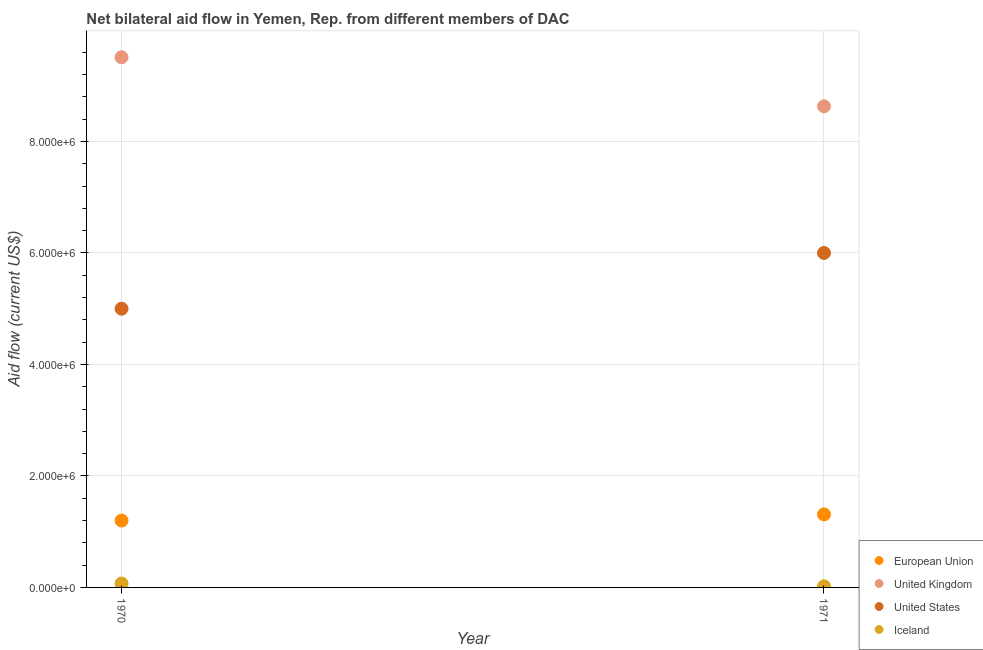How many different coloured dotlines are there?
Provide a succinct answer. 4. What is the amount of aid given by eu in 1971?
Your answer should be very brief. 1.31e+06. Across all years, what is the maximum amount of aid given by eu?
Your answer should be compact. 1.31e+06. Across all years, what is the minimum amount of aid given by eu?
Keep it short and to the point. 1.20e+06. In which year was the amount of aid given by us maximum?
Your response must be concise. 1971. In which year was the amount of aid given by us minimum?
Make the answer very short. 1970. What is the total amount of aid given by uk in the graph?
Your answer should be compact. 1.81e+07. What is the difference between the amount of aid given by iceland in 1970 and that in 1971?
Offer a very short reply. 5.00e+04. What is the difference between the amount of aid given by iceland in 1970 and the amount of aid given by us in 1971?
Offer a terse response. -5.93e+06. What is the average amount of aid given by us per year?
Provide a short and direct response. 5.50e+06. In the year 1971, what is the difference between the amount of aid given by us and amount of aid given by eu?
Make the answer very short. 4.69e+06. What is the ratio of the amount of aid given by uk in 1970 to that in 1971?
Keep it short and to the point. 1.1. Is the amount of aid given by uk in 1970 less than that in 1971?
Your answer should be very brief. No. In how many years, is the amount of aid given by eu greater than the average amount of aid given by eu taken over all years?
Your response must be concise. 1. Does the amount of aid given by iceland monotonically increase over the years?
Your response must be concise. No. How many years are there in the graph?
Offer a very short reply. 2. Are the values on the major ticks of Y-axis written in scientific E-notation?
Provide a succinct answer. Yes. Does the graph contain any zero values?
Keep it short and to the point. No. Does the graph contain grids?
Offer a terse response. Yes. Where does the legend appear in the graph?
Give a very brief answer. Bottom right. How many legend labels are there?
Give a very brief answer. 4. How are the legend labels stacked?
Your answer should be very brief. Vertical. What is the title of the graph?
Ensure brevity in your answer.  Net bilateral aid flow in Yemen, Rep. from different members of DAC. Does "Management rating" appear as one of the legend labels in the graph?
Provide a succinct answer. No. What is the label or title of the Y-axis?
Offer a terse response. Aid flow (current US$). What is the Aid flow (current US$) of European Union in 1970?
Keep it short and to the point. 1.20e+06. What is the Aid flow (current US$) in United Kingdom in 1970?
Your answer should be compact. 9.51e+06. What is the Aid flow (current US$) in United States in 1970?
Make the answer very short. 5.00e+06. What is the Aid flow (current US$) in Iceland in 1970?
Your answer should be very brief. 7.00e+04. What is the Aid flow (current US$) in European Union in 1971?
Ensure brevity in your answer.  1.31e+06. What is the Aid flow (current US$) in United Kingdom in 1971?
Keep it short and to the point. 8.63e+06. What is the Aid flow (current US$) of United States in 1971?
Keep it short and to the point. 6.00e+06. What is the Aid flow (current US$) in Iceland in 1971?
Provide a succinct answer. 2.00e+04. Across all years, what is the maximum Aid flow (current US$) of European Union?
Your response must be concise. 1.31e+06. Across all years, what is the maximum Aid flow (current US$) in United Kingdom?
Provide a succinct answer. 9.51e+06. Across all years, what is the minimum Aid flow (current US$) in European Union?
Provide a short and direct response. 1.20e+06. Across all years, what is the minimum Aid flow (current US$) of United Kingdom?
Your response must be concise. 8.63e+06. What is the total Aid flow (current US$) of European Union in the graph?
Give a very brief answer. 2.51e+06. What is the total Aid flow (current US$) of United Kingdom in the graph?
Your answer should be very brief. 1.81e+07. What is the total Aid flow (current US$) of United States in the graph?
Give a very brief answer. 1.10e+07. What is the difference between the Aid flow (current US$) in European Union in 1970 and that in 1971?
Provide a short and direct response. -1.10e+05. What is the difference between the Aid flow (current US$) of United Kingdom in 1970 and that in 1971?
Give a very brief answer. 8.80e+05. What is the difference between the Aid flow (current US$) in Iceland in 1970 and that in 1971?
Offer a terse response. 5.00e+04. What is the difference between the Aid flow (current US$) in European Union in 1970 and the Aid flow (current US$) in United Kingdom in 1971?
Your answer should be very brief. -7.43e+06. What is the difference between the Aid flow (current US$) of European Union in 1970 and the Aid flow (current US$) of United States in 1971?
Make the answer very short. -4.80e+06. What is the difference between the Aid flow (current US$) of European Union in 1970 and the Aid flow (current US$) of Iceland in 1971?
Provide a succinct answer. 1.18e+06. What is the difference between the Aid flow (current US$) of United Kingdom in 1970 and the Aid flow (current US$) of United States in 1971?
Offer a terse response. 3.51e+06. What is the difference between the Aid flow (current US$) of United Kingdom in 1970 and the Aid flow (current US$) of Iceland in 1971?
Give a very brief answer. 9.49e+06. What is the difference between the Aid flow (current US$) of United States in 1970 and the Aid flow (current US$) of Iceland in 1971?
Ensure brevity in your answer.  4.98e+06. What is the average Aid flow (current US$) in European Union per year?
Your response must be concise. 1.26e+06. What is the average Aid flow (current US$) in United Kingdom per year?
Ensure brevity in your answer.  9.07e+06. What is the average Aid flow (current US$) of United States per year?
Give a very brief answer. 5.50e+06. What is the average Aid flow (current US$) in Iceland per year?
Make the answer very short. 4.50e+04. In the year 1970, what is the difference between the Aid flow (current US$) in European Union and Aid flow (current US$) in United Kingdom?
Offer a very short reply. -8.31e+06. In the year 1970, what is the difference between the Aid flow (current US$) in European Union and Aid flow (current US$) in United States?
Your answer should be very brief. -3.80e+06. In the year 1970, what is the difference between the Aid flow (current US$) in European Union and Aid flow (current US$) in Iceland?
Provide a short and direct response. 1.13e+06. In the year 1970, what is the difference between the Aid flow (current US$) of United Kingdom and Aid flow (current US$) of United States?
Offer a terse response. 4.51e+06. In the year 1970, what is the difference between the Aid flow (current US$) of United Kingdom and Aid flow (current US$) of Iceland?
Your answer should be compact. 9.44e+06. In the year 1970, what is the difference between the Aid flow (current US$) in United States and Aid flow (current US$) in Iceland?
Your answer should be very brief. 4.93e+06. In the year 1971, what is the difference between the Aid flow (current US$) in European Union and Aid flow (current US$) in United Kingdom?
Give a very brief answer. -7.32e+06. In the year 1971, what is the difference between the Aid flow (current US$) in European Union and Aid flow (current US$) in United States?
Offer a terse response. -4.69e+06. In the year 1971, what is the difference between the Aid flow (current US$) in European Union and Aid flow (current US$) in Iceland?
Offer a terse response. 1.29e+06. In the year 1971, what is the difference between the Aid flow (current US$) of United Kingdom and Aid flow (current US$) of United States?
Provide a short and direct response. 2.63e+06. In the year 1971, what is the difference between the Aid flow (current US$) in United Kingdom and Aid flow (current US$) in Iceland?
Ensure brevity in your answer.  8.61e+06. In the year 1971, what is the difference between the Aid flow (current US$) of United States and Aid flow (current US$) of Iceland?
Keep it short and to the point. 5.98e+06. What is the ratio of the Aid flow (current US$) in European Union in 1970 to that in 1971?
Offer a terse response. 0.92. What is the ratio of the Aid flow (current US$) of United Kingdom in 1970 to that in 1971?
Your response must be concise. 1.1. What is the difference between the highest and the second highest Aid flow (current US$) of European Union?
Give a very brief answer. 1.10e+05. What is the difference between the highest and the second highest Aid flow (current US$) in United Kingdom?
Offer a terse response. 8.80e+05. What is the difference between the highest and the second highest Aid flow (current US$) of United States?
Your answer should be very brief. 1.00e+06. What is the difference between the highest and the second highest Aid flow (current US$) in Iceland?
Offer a terse response. 5.00e+04. What is the difference between the highest and the lowest Aid flow (current US$) of European Union?
Your answer should be compact. 1.10e+05. What is the difference between the highest and the lowest Aid flow (current US$) of United Kingdom?
Your answer should be very brief. 8.80e+05. 